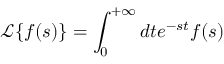<formula> <loc_0><loc_0><loc_500><loc_500>\mathcal { L } \{ f ( s ) \} = \int _ { 0 } ^ { + \infty } d t e ^ { - s t } f ( s )</formula> 